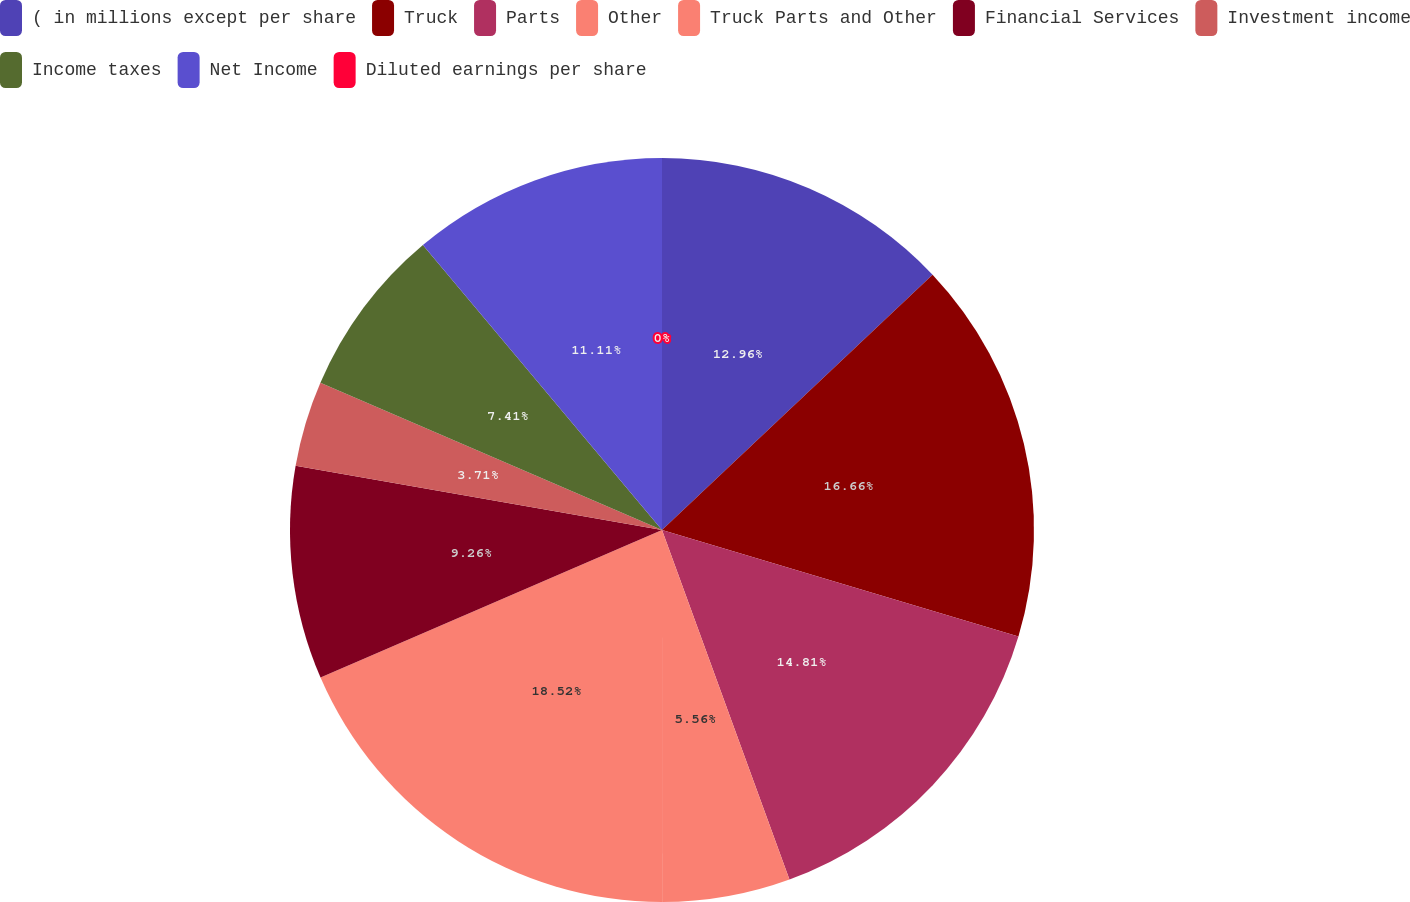<chart> <loc_0><loc_0><loc_500><loc_500><pie_chart><fcel>( in millions except per share<fcel>Truck<fcel>Parts<fcel>Other<fcel>Truck Parts and Other<fcel>Financial Services<fcel>Investment income<fcel>Income taxes<fcel>Net Income<fcel>Diluted earnings per share<nl><fcel>12.96%<fcel>16.66%<fcel>14.81%<fcel>5.56%<fcel>18.51%<fcel>9.26%<fcel>3.71%<fcel>7.41%<fcel>11.11%<fcel>0.0%<nl></chart> 